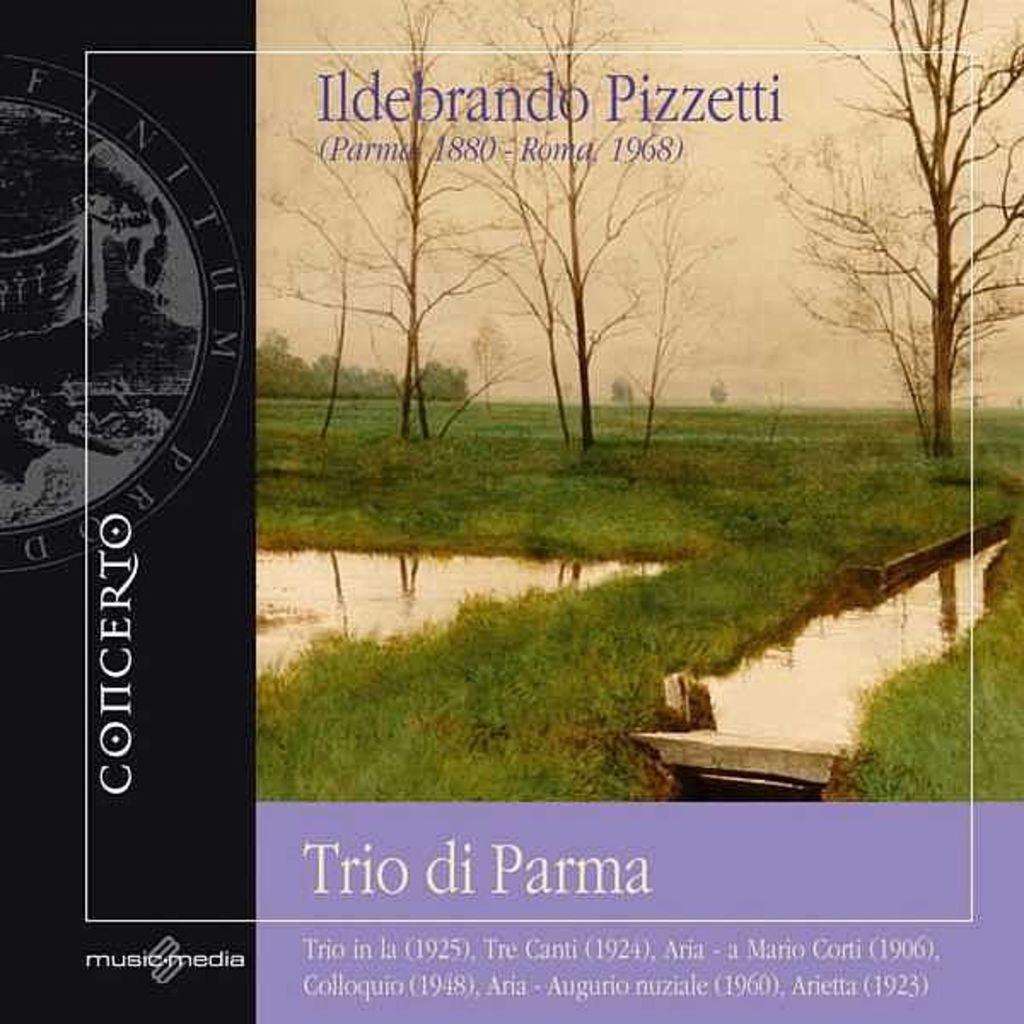Can you describe this image briefly? In this image we can see a book cover. On the cover there are trees, grass and water. At the top there is sky and we can see text. 